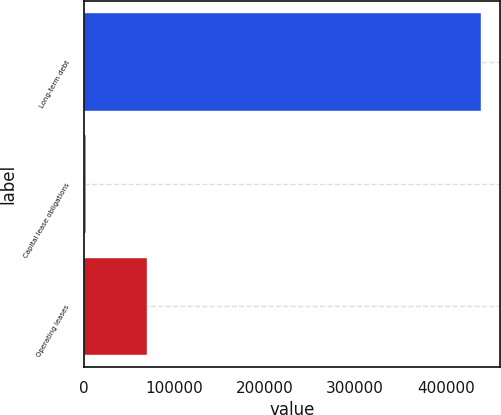Convert chart. <chart><loc_0><loc_0><loc_500><loc_500><bar_chart><fcel>Long-term debt<fcel>Capital lease obligations<fcel>Operating leases<nl><fcel>438437<fcel>2380<fcel>69832<nl></chart> 